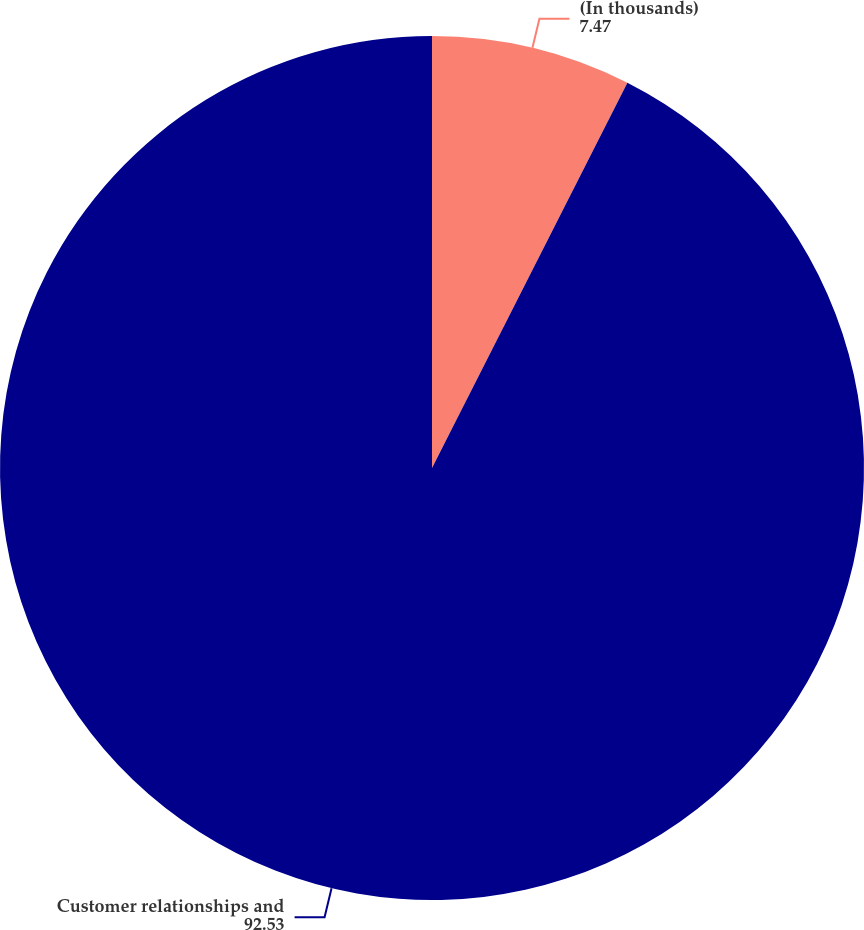Convert chart to OTSL. <chart><loc_0><loc_0><loc_500><loc_500><pie_chart><fcel>(In thousands)<fcel>Customer relationships and<nl><fcel>7.47%<fcel>92.53%<nl></chart> 